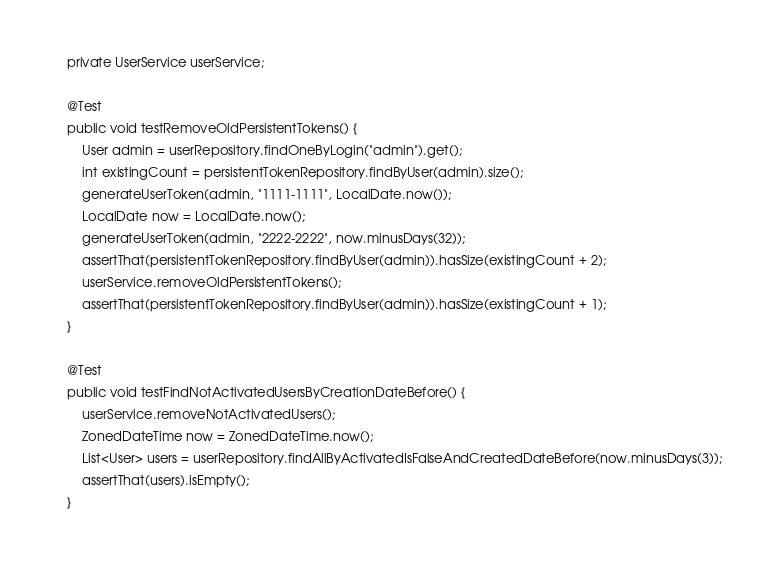Convert code to text. <code><loc_0><loc_0><loc_500><loc_500><_Java_>    private UserService userService;

    @Test
    public void testRemoveOldPersistentTokens() {
        User admin = userRepository.findOneByLogin("admin").get();
        int existingCount = persistentTokenRepository.findByUser(admin).size();
        generateUserToken(admin, "1111-1111", LocalDate.now());
        LocalDate now = LocalDate.now();
        generateUserToken(admin, "2222-2222", now.minusDays(32));
        assertThat(persistentTokenRepository.findByUser(admin)).hasSize(existingCount + 2);
        userService.removeOldPersistentTokens();
        assertThat(persistentTokenRepository.findByUser(admin)).hasSize(existingCount + 1);
    }

    @Test
    public void testFindNotActivatedUsersByCreationDateBefore() {
        userService.removeNotActivatedUsers();
        ZonedDateTime now = ZonedDateTime.now();
        List<User> users = userRepository.findAllByActivatedIsFalseAndCreatedDateBefore(now.minusDays(3));
        assertThat(users).isEmpty();
    }
</code> 